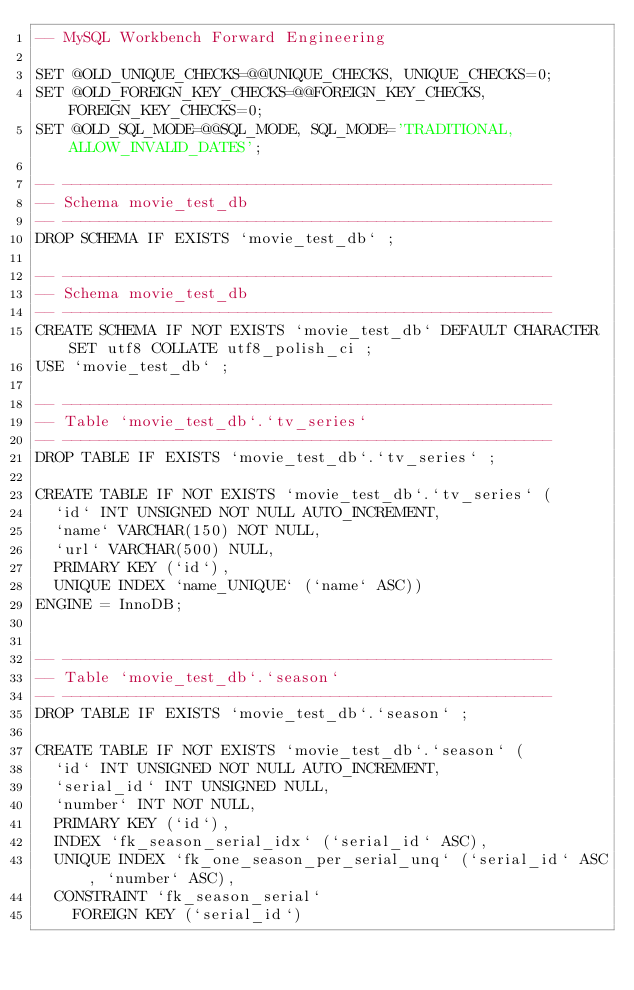<code> <loc_0><loc_0><loc_500><loc_500><_SQL_>-- MySQL Workbench Forward Engineering

SET @OLD_UNIQUE_CHECKS=@@UNIQUE_CHECKS, UNIQUE_CHECKS=0;
SET @OLD_FOREIGN_KEY_CHECKS=@@FOREIGN_KEY_CHECKS, FOREIGN_KEY_CHECKS=0;
SET @OLD_SQL_MODE=@@SQL_MODE, SQL_MODE='TRADITIONAL,ALLOW_INVALID_DATES';

-- -----------------------------------------------------
-- Schema movie_test_db
-- -----------------------------------------------------
DROP SCHEMA IF EXISTS `movie_test_db` ;

-- -----------------------------------------------------
-- Schema movie_test_db
-- -----------------------------------------------------
CREATE SCHEMA IF NOT EXISTS `movie_test_db` DEFAULT CHARACTER SET utf8 COLLATE utf8_polish_ci ;
USE `movie_test_db` ;

-- -----------------------------------------------------
-- Table `movie_test_db`.`tv_series`
-- -----------------------------------------------------
DROP TABLE IF EXISTS `movie_test_db`.`tv_series` ;

CREATE TABLE IF NOT EXISTS `movie_test_db`.`tv_series` (
  `id` INT UNSIGNED NOT NULL AUTO_INCREMENT,
  `name` VARCHAR(150) NOT NULL,
  `url` VARCHAR(500) NULL,
  PRIMARY KEY (`id`),
  UNIQUE INDEX `name_UNIQUE` (`name` ASC))
ENGINE = InnoDB;


-- -----------------------------------------------------
-- Table `movie_test_db`.`season`
-- -----------------------------------------------------
DROP TABLE IF EXISTS `movie_test_db`.`season` ;

CREATE TABLE IF NOT EXISTS `movie_test_db`.`season` (
  `id` INT UNSIGNED NOT NULL AUTO_INCREMENT,
  `serial_id` INT UNSIGNED NULL,
  `number` INT NOT NULL,
  PRIMARY KEY (`id`),
  INDEX `fk_season_serial_idx` (`serial_id` ASC),
  UNIQUE INDEX `fk_one_season_per_serial_unq` (`serial_id` ASC, `number` ASC),
  CONSTRAINT `fk_season_serial`
    FOREIGN KEY (`serial_id`)</code> 